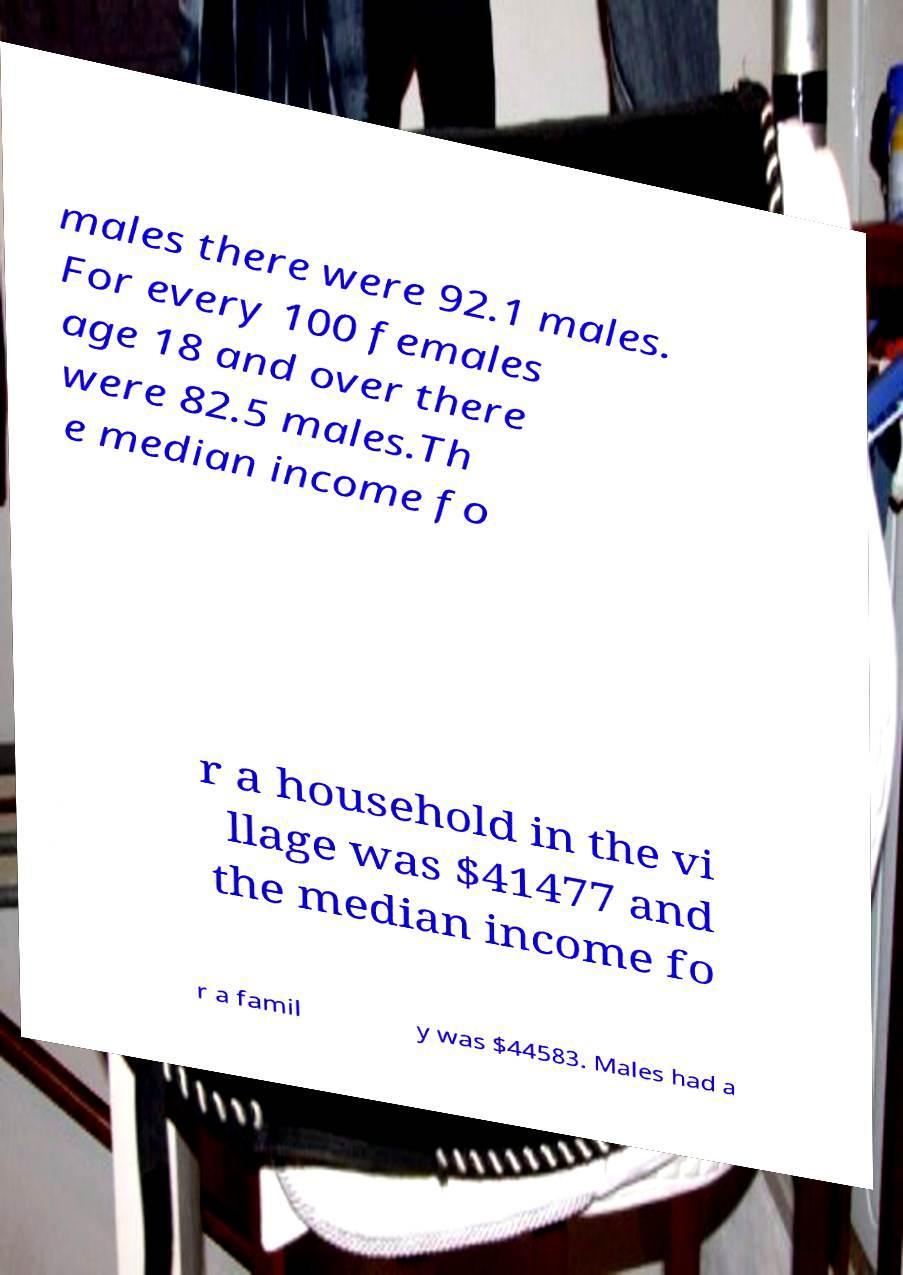What messages or text are displayed in this image? I need them in a readable, typed format. males there were 92.1 males. For every 100 females age 18 and over there were 82.5 males.Th e median income fo r a household in the vi llage was $41477 and the median income fo r a famil y was $44583. Males had a 